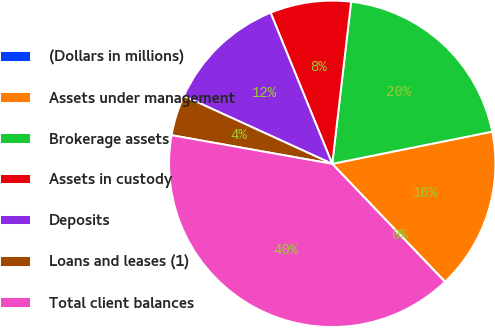Convert chart to OTSL. <chart><loc_0><loc_0><loc_500><loc_500><pie_chart><fcel>(Dollars in millions)<fcel>Assets under management<fcel>Brokerage assets<fcel>Assets in custody<fcel>Deposits<fcel>Loans and leases (1)<fcel>Total client balances<nl><fcel>0.03%<fcel>16.0%<fcel>19.99%<fcel>8.01%<fcel>12.01%<fcel>4.02%<fcel>39.94%<nl></chart> 